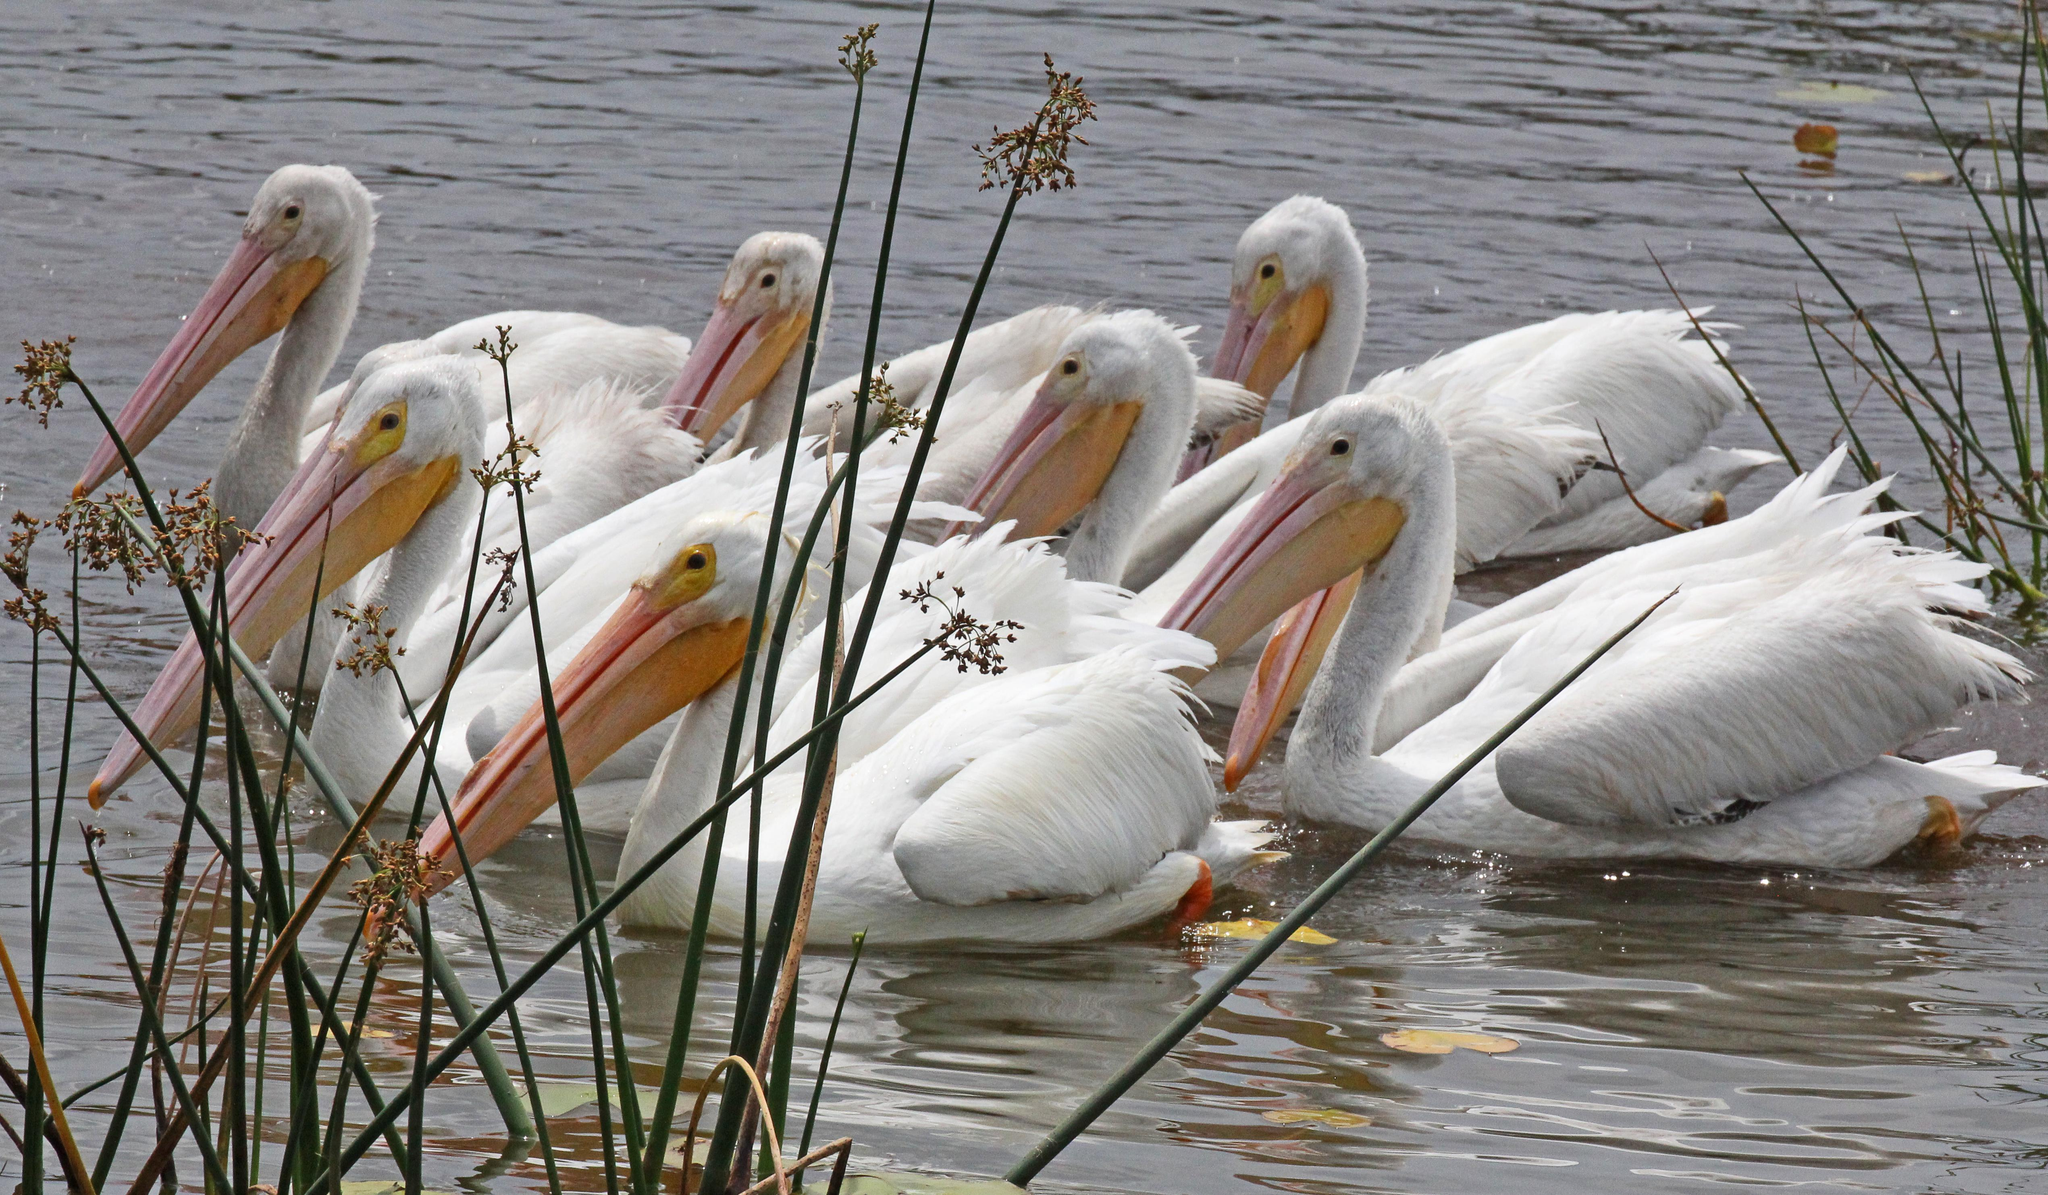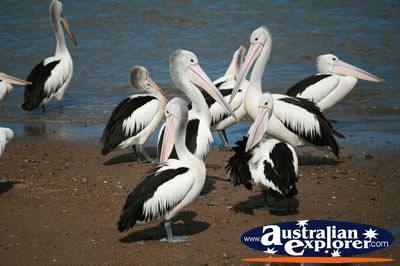The first image is the image on the left, the second image is the image on the right. Examine the images to the left and right. Is the description "there is a flying bird in the image on the right" accurate? Answer yes or no. No. The first image is the image on the left, the second image is the image on the right. Assess this claim about the two images: "At least one bird is flying.". Correct or not? Answer yes or no. No. 